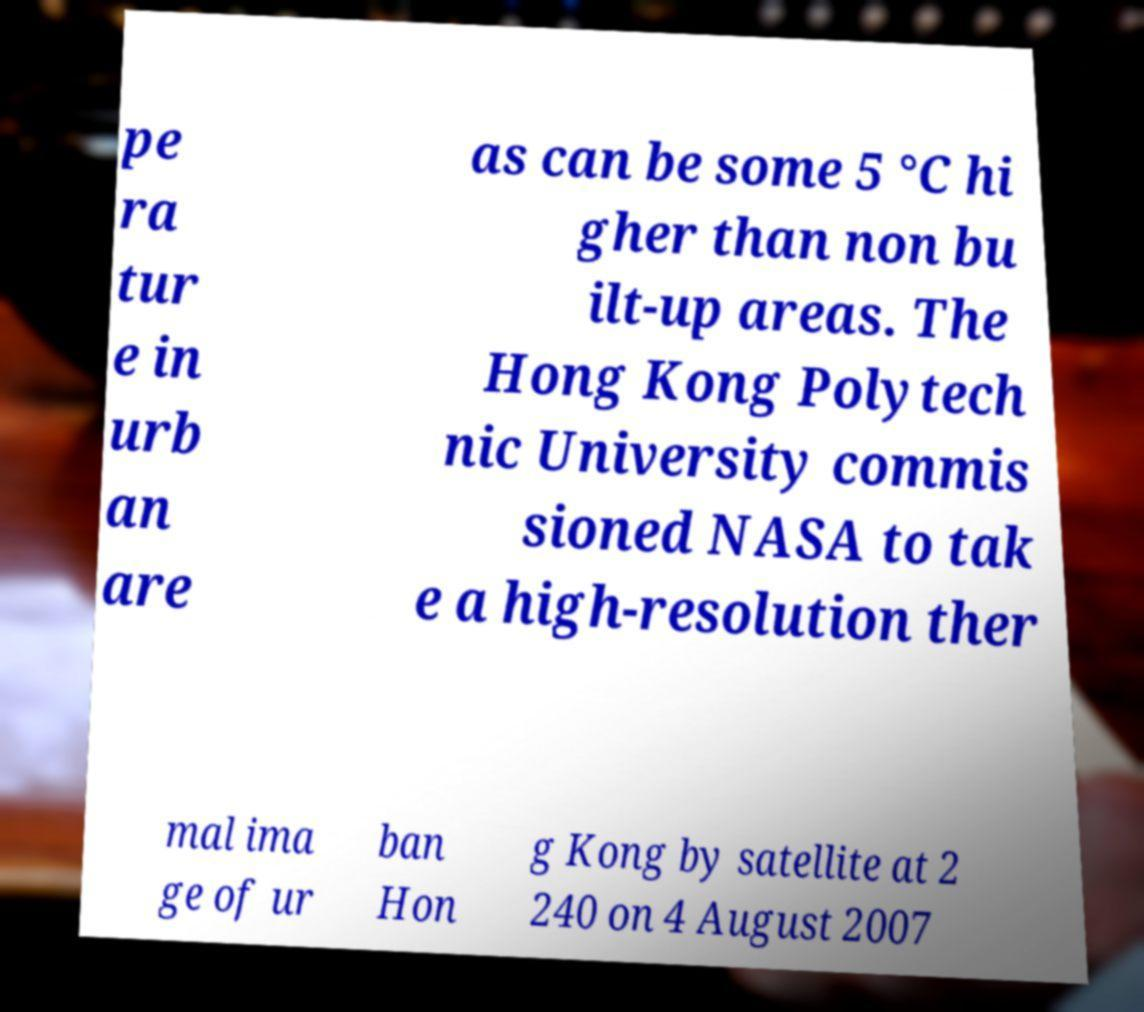Could you assist in decoding the text presented in this image and type it out clearly? pe ra tur e in urb an are as can be some 5 °C hi gher than non bu ilt-up areas. The Hong Kong Polytech nic University commis sioned NASA to tak e a high-resolution ther mal ima ge of ur ban Hon g Kong by satellite at 2 240 on 4 August 2007 